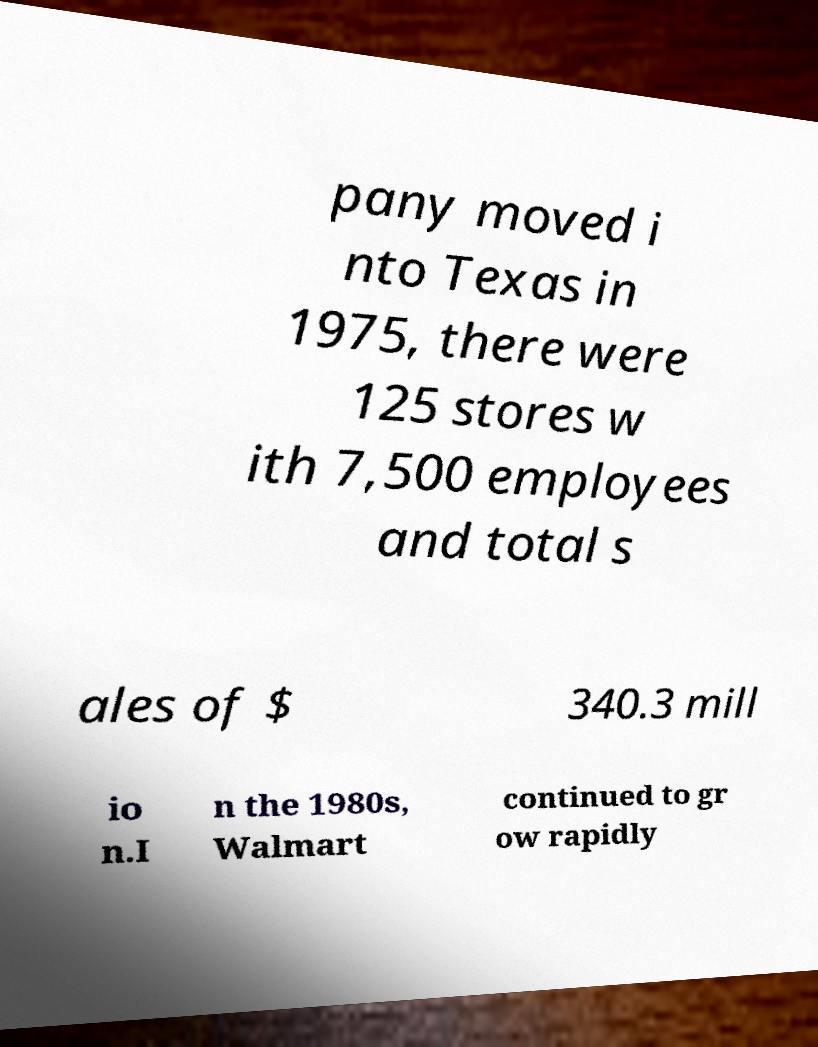There's text embedded in this image that I need extracted. Can you transcribe it verbatim? pany moved i nto Texas in 1975, there were 125 stores w ith 7,500 employees and total s ales of $ 340.3 mill io n.I n the 1980s, Walmart continued to gr ow rapidly 